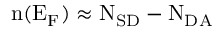Convert formula to latex. <formula><loc_0><loc_0><loc_500><loc_500>n ( E _ { F } ) \approx N _ { S D } - N _ { D A }</formula> 